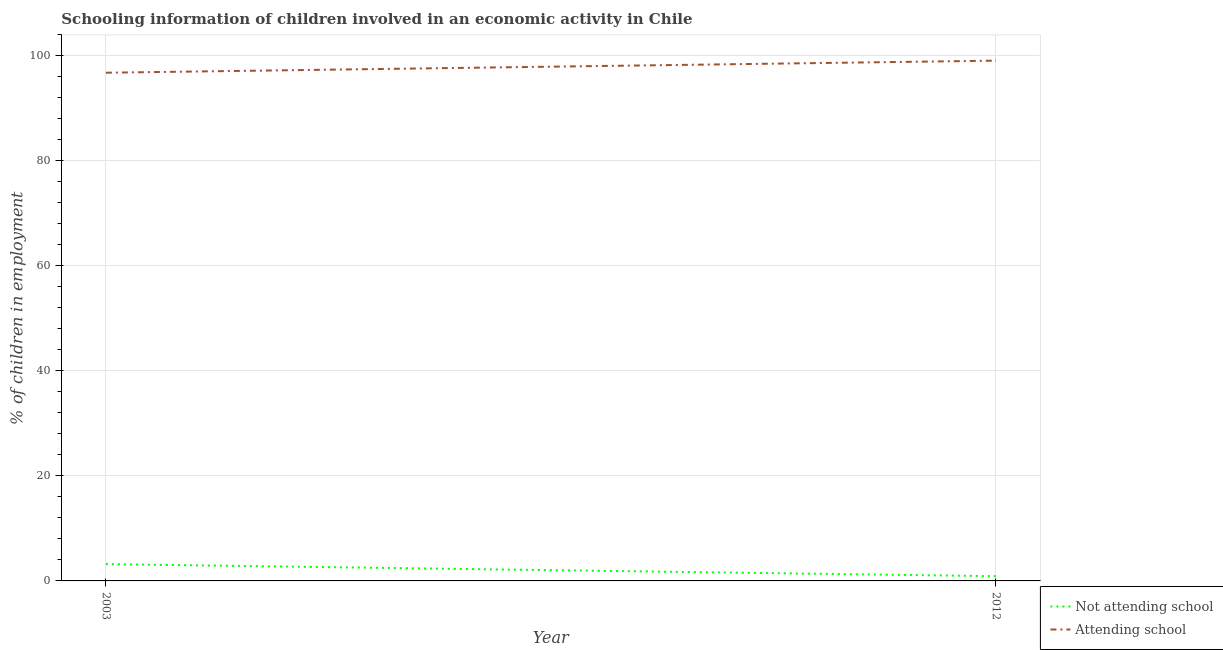Does the line corresponding to percentage of employed children who are attending school intersect with the line corresponding to percentage of employed children who are not attending school?
Provide a short and direct response. No. Is the number of lines equal to the number of legend labels?
Your answer should be very brief. Yes. What is the percentage of employed children who are not attending school in 2012?
Provide a short and direct response. 0.9. Across all years, what is the maximum percentage of employed children who are not attending school?
Give a very brief answer. 3.2. Across all years, what is the minimum percentage of employed children who are not attending school?
Your answer should be compact. 0.9. In which year was the percentage of employed children who are attending school minimum?
Make the answer very short. 2003. What is the total percentage of employed children who are not attending school in the graph?
Provide a succinct answer. 4.1. What is the difference between the percentage of employed children who are attending school in 2003 and that in 2012?
Keep it short and to the point. -2.3. What is the difference between the percentage of employed children who are not attending school in 2012 and the percentage of employed children who are attending school in 2003?
Your response must be concise. -95.9. What is the average percentage of employed children who are not attending school per year?
Make the answer very short. 2.05. In the year 2003, what is the difference between the percentage of employed children who are attending school and percentage of employed children who are not attending school?
Offer a very short reply. 93.6. What is the ratio of the percentage of employed children who are not attending school in 2003 to that in 2012?
Provide a succinct answer. 3.56. Is the percentage of employed children who are not attending school in 2003 less than that in 2012?
Provide a succinct answer. No. Is the percentage of employed children who are attending school strictly less than the percentage of employed children who are not attending school over the years?
Offer a terse response. No. How many years are there in the graph?
Ensure brevity in your answer.  2. Are the values on the major ticks of Y-axis written in scientific E-notation?
Your response must be concise. No. Does the graph contain any zero values?
Provide a short and direct response. No. How many legend labels are there?
Your answer should be very brief. 2. What is the title of the graph?
Give a very brief answer. Schooling information of children involved in an economic activity in Chile. What is the label or title of the X-axis?
Provide a succinct answer. Year. What is the label or title of the Y-axis?
Your response must be concise. % of children in employment. What is the % of children in employment in Attending school in 2003?
Offer a terse response. 96.8. What is the % of children in employment in Not attending school in 2012?
Provide a succinct answer. 0.9. What is the % of children in employment in Attending school in 2012?
Ensure brevity in your answer.  99.1. Across all years, what is the maximum % of children in employment in Not attending school?
Your response must be concise. 3.2. Across all years, what is the maximum % of children in employment of Attending school?
Your answer should be very brief. 99.1. Across all years, what is the minimum % of children in employment in Attending school?
Provide a short and direct response. 96.8. What is the total % of children in employment in Not attending school in the graph?
Offer a terse response. 4.1. What is the total % of children in employment of Attending school in the graph?
Ensure brevity in your answer.  195.9. What is the difference between the % of children in employment of Not attending school in 2003 and the % of children in employment of Attending school in 2012?
Provide a short and direct response. -95.9. What is the average % of children in employment in Not attending school per year?
Ensure brevity in your answer.  2.05. What is the average % of children in employment of Attending school per year?
Your answer should be very brief. 97.95. In the year 2003, what is the difference between the % of children in employment of Not attending school and % of children in employment of Attending school?
Your answer should be compact. -93.6. In the year 2012, what is the difference between the % of children in employment in Not attending school and % of children in employment in Attending school?
Provide a short and direct response. -98.2. What is the ratio of the % of children in employment of Not attending school in 2003 to that in 2012?
Give a very brief answer. 3.56. What is the ratio of the % of children in employment in Attending school in 2003 to that in 2012?
Offer a terse response. 0.98. What is the difference between the highest and the second highest % of children in employment in Not attending school?
Ensure brevity in your answer.  2.3. What is the difference between the highest and the lowest % of children in employment of Attending school?
Offer a terse response. 2.3. 